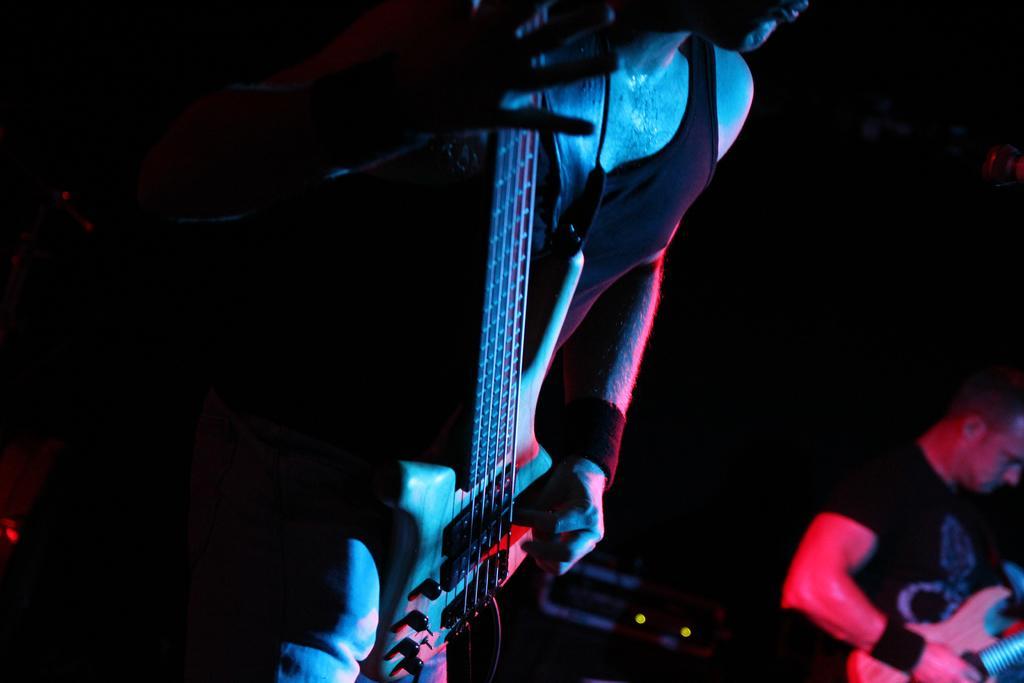Could you give a brief overview of what you see in this image? In the image we see there is a person who is holding a guitar in his hand and beside him there another person who is also holding a guitar in his hand. 